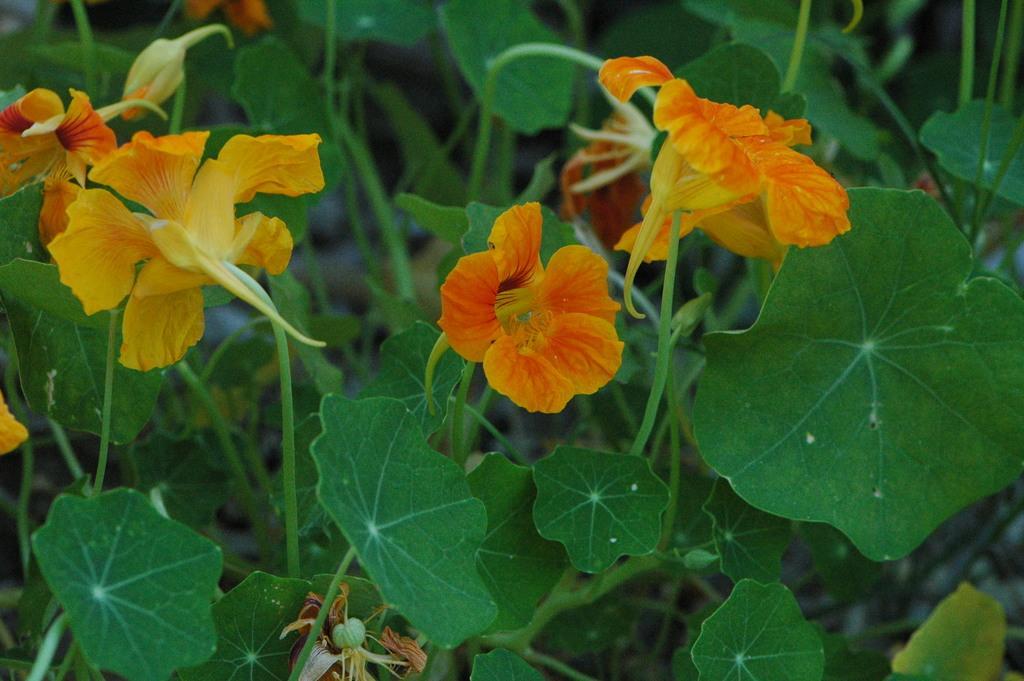Could you give a brief overview of what you see in this image? In this picture I can see there are plants here and there are some yellow flowers to the plants. 